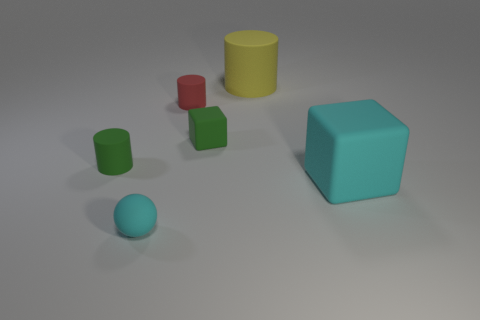Are there the same number of red cylinders that are behind the tiny red cylinder and big yellow cylinders?
Give a very brief answer. No. How many other things are there of the same material as the yellow cylinder?
Your response must be concise. 5. There is a cyan rubber thing that is in front of the big cyan cube; is it the same size as the matte cylinder in front of the tiny green cube?
Make the answer very short. Yes. How many things are cyan things to the right of the tiny cyan sphere or rubber things that are in front of the big cyan cube?
Provide a short and direct response. 2. Is there any other thing that is the same shape as the yellow matte object?
Your answer should be compact. Yes. There is a tiny cylinder that is on the right side of the small cyan ball; does it have the same color as the block to the right of the green matte block?
Give a very brief answer. No. How many metal objects are either green objects or tiny green blocks?
Make the answer very short. 0. Are there any other things that have the same size as the green matte cube?
Keep it short and to the point. Yes. The cyan matte object on the right side of the large thing that is behind the small red rubber cylinder is what shape?
Ensure brevity in your answer.  Cube. Do the tiny green thing to the left of the red rubber thing and the cylinder right of the tiny green cube have the same material?
Your answer should be compact. Yes. 